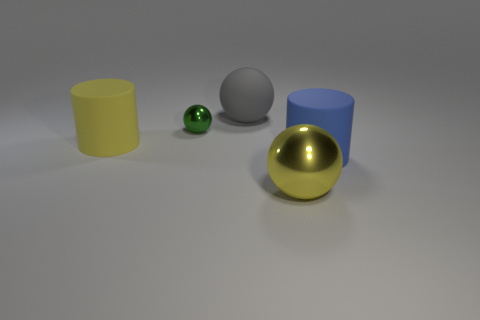Subtract all purple balls. Subtract all blue cylinders. How many balls are left? 3 Add 4 large red spheres. How many objects exist? 9 Subtract all cylinders. How many objects are left? 3 Subtract all tiny shiny things. Subtract all blue rubber cylinders. How many objects are left? 3 Add 3 tiny things. How many tiny things are left? 4 Add 4 tiny green matte spheres. How many tiny green matte spheres exist? 4 Subtract 0 brown cylinders. How many objects are left? 5 